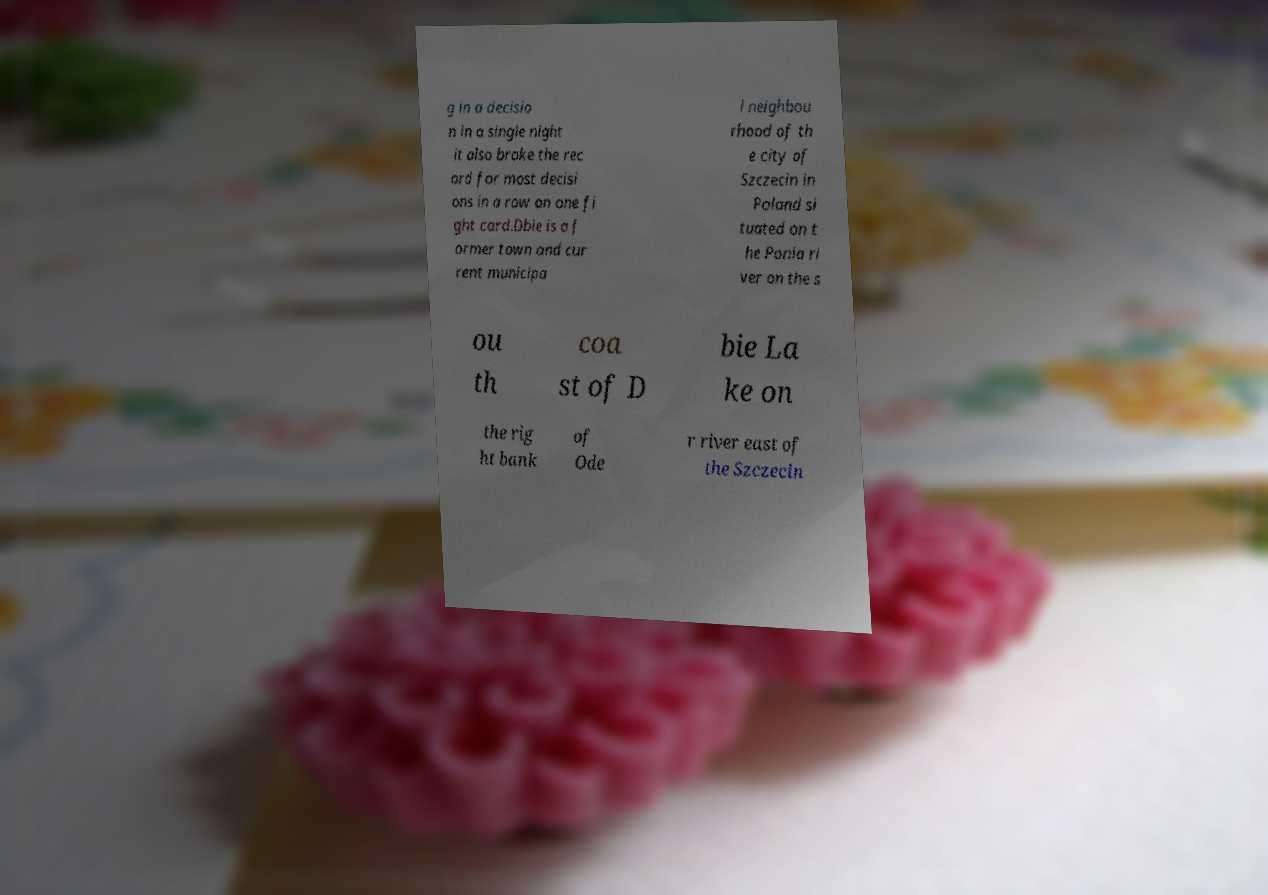Could you extract and type out the text from this image? g in a decisio n in a single night it also broke the rec ord for most decisi ons in a row on one fi ght card.Dbie is a f ormer town and cur rent municipa l neighbou rhood of th e city of Szczecin in Poland si tuated on t he Ponia ri ver on the s ou th coa st of D bie La ke on the rig ht bank of Ode r river east of the Szczecin 